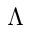<formula> <loc_0><loc_0><loc_500><loc_500>\Lambda</formula> 